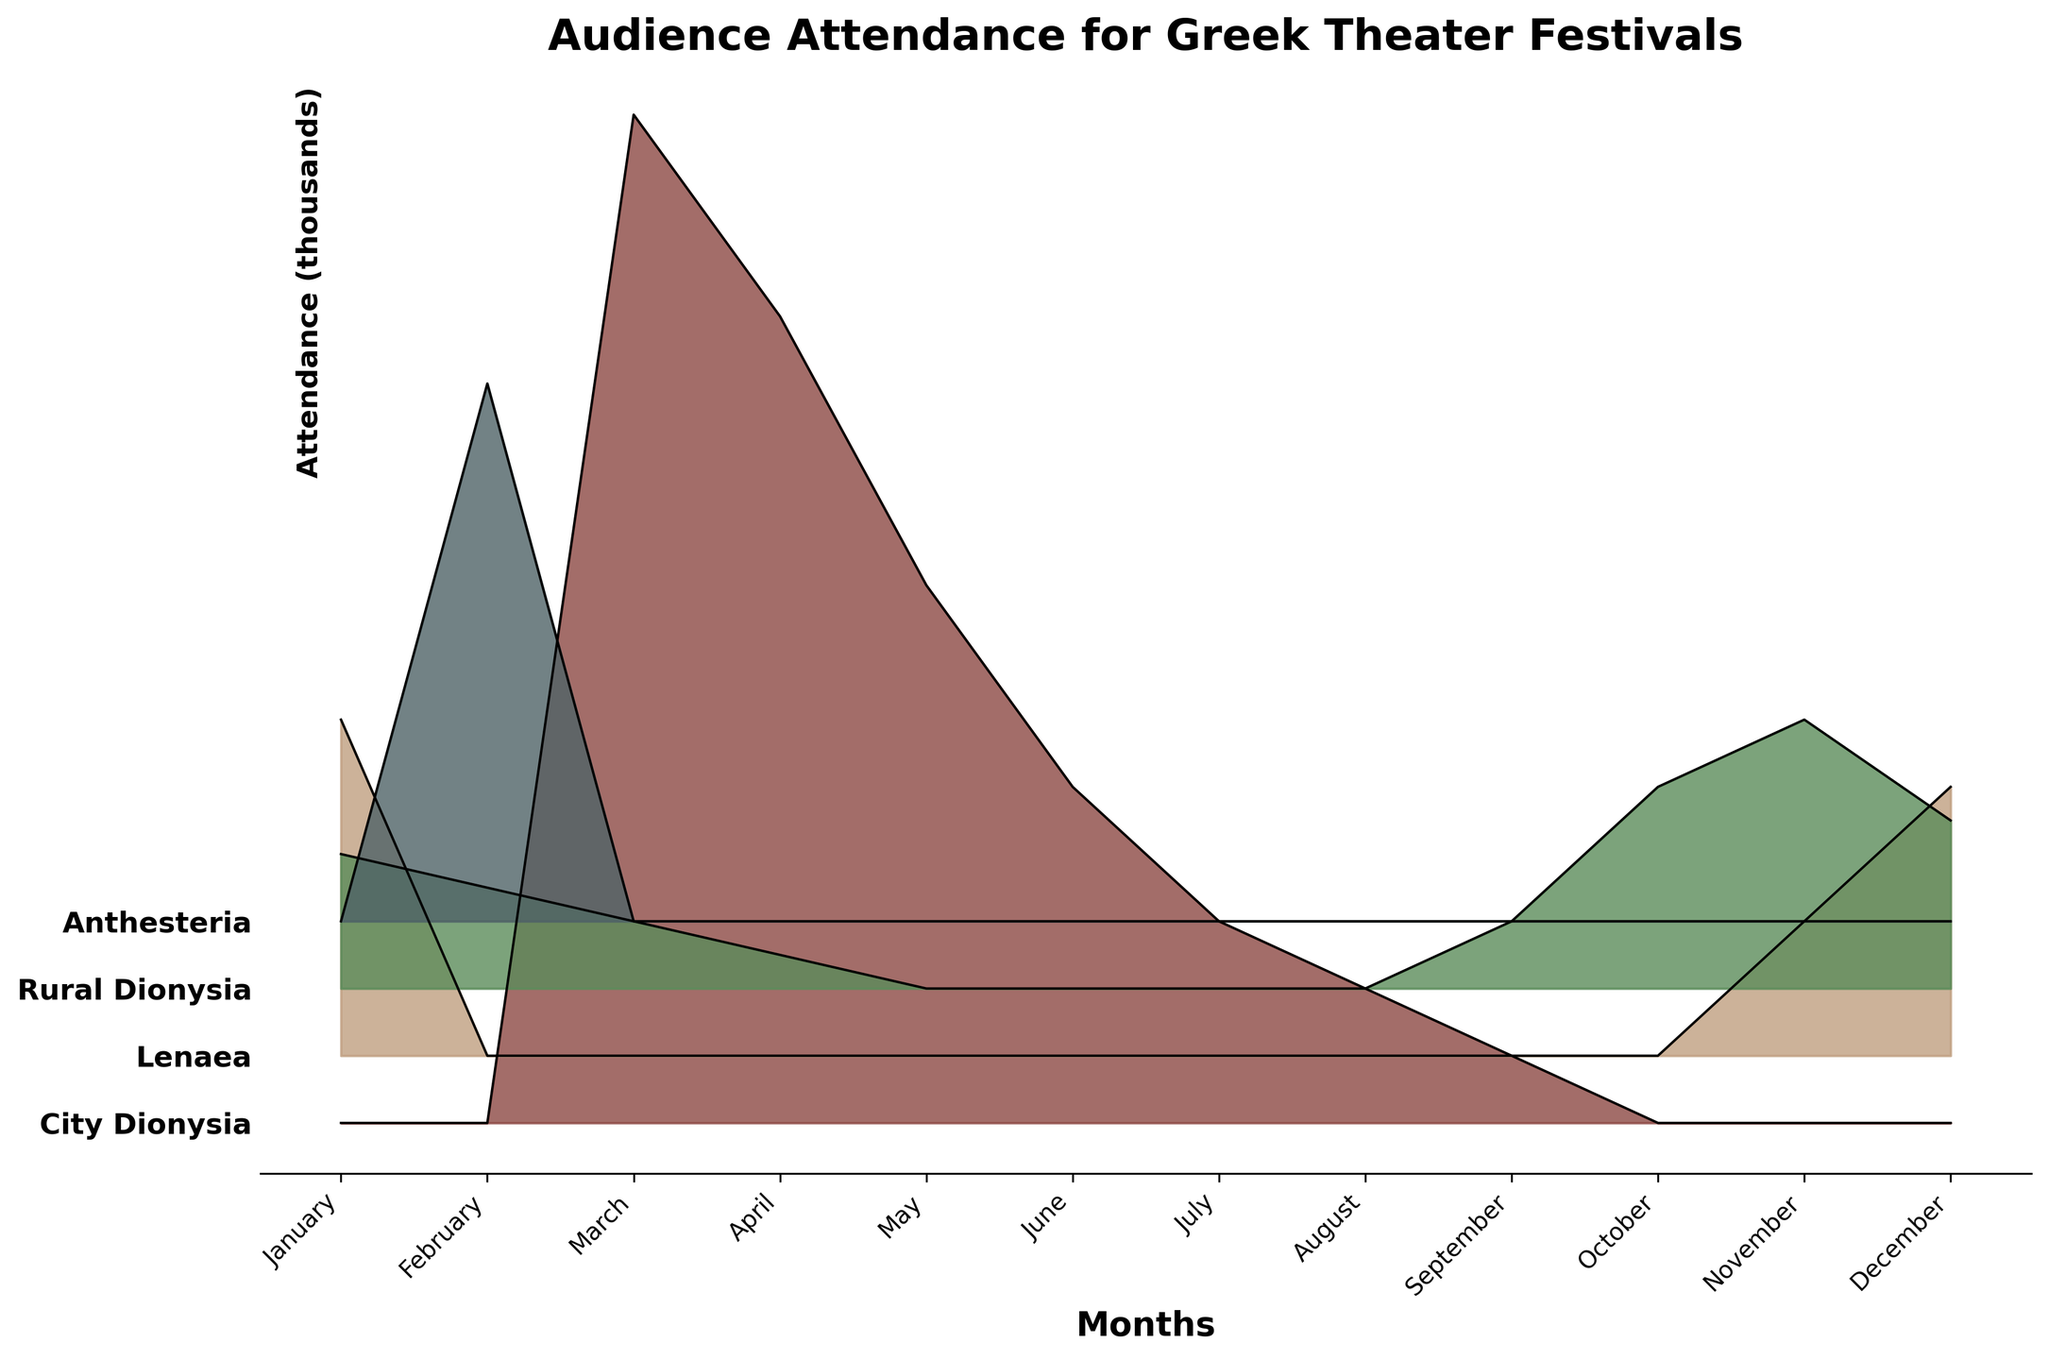What is the title of the figure? The title is usually indicated at the top of the plot in a bold font. In this case, it reads "Audience Attendance for Greek Theater Festivals".
Answer: Audience Attendance for Greek Theater Festivals Which month has the highest audience attendance for the City Dionysia? To find the month with the highest attendance, look at the height of the ridgeline plot for City Dionysia. The tallest peak corresponds to March.
Answer: March How does the audience attendance for the City Dionysia in March compare to that in June? Compare the heights of the ridgeline plot for the City Dionysia in March and June. March has a higher peak, indicating more attendees. Specifically, March has about 15,000 attendees, while June has about 5,000.
Answer: March is higher What is the average audience attendance for the Lenaea festival across the months shown? Sum the attendance values for the Lenaea festival across all months and divide by the number of months with non-zero attendance. The Lenaea has attendance in January (5000), November (2000), and December (4000). The total is 11,000, and averaging over 3 months gives 11,000 / 3 ≈ 3667.
Answer: 3667 Which festival has no attendees in the month of January? Identify the festival line that starts at 0 and ends flat at the 0 mark in January. Both City Dionysia and Anthesteria have no attendees in January.
Answer: City Dionysia and Anthesteria What is the total audience attendance for November across all festivals? Sum the attendance numbers for all festivals in November. The values are Lenaea (2000), Rural Dionysia (4000), and adding those together results in 6000.
Answer: 6000 In which months do we see attendance for the Anthesteria festival? Look at the non-zero values for the Anthesteria festival across the months. Anthesteria sees attendance only in February.
Answer: February How does attendance at the Rural Dionysia in November compare to the attendance at Anthesteria in February? Compare the heights of the ridgeline plots. Both have peaks, but Rural Dionysia in November has 4000 attendees and Anthesteria in February has 8000.
Answer: Anthesteria is higher Which festival shows a trend of declining attendance from March to July? Identify the line that decreases in height from March through to July. The City Dionysia's attendance decreases from 15000 to 12000 in April, 8000 in May, 5000 in June, and 3000 in July.
Answer: City Dionysia What is the difference in audience attendance for the Rural Dionysia between January and December? Find the attendance values for the Rural Dionysia in January and December and subtract one from the other. January has 2000 attendees and December has 2500, resulting in a difference of 2500 - 2000 = 500.
Answer: 500 